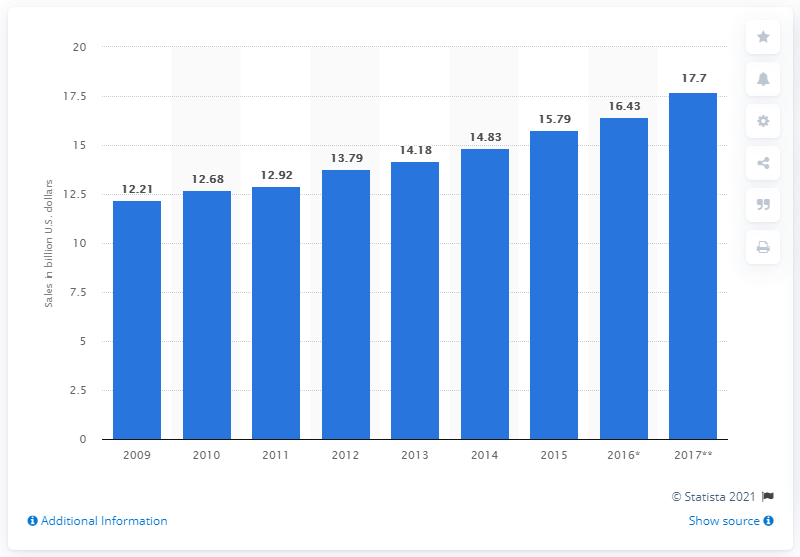Give some essential details in this illustration. In 2017, the sales forecast for restaurants located in recreation and sports places was 17.7%. 